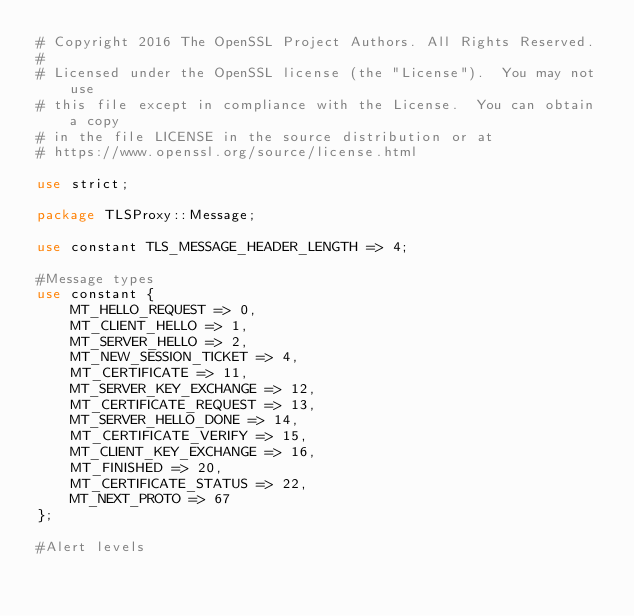<code> <loc_0><loc_0><loc_500><loc_500><_Perl_># Copyright 2016 The OpenSSL Project Authors. All Rights Reserved.
#
# Licensed under the OpenSSL license (the "License").  You may not use
# this file except in compliance with the License.  You can obtain a copy
# in the file LICENSE in the source distribution or at
# https://www.openssl.org/source/license.html

use strict;

package TLSProxy::Message;

use constant TLS_MESSAGE_HEADER_LENGTH => 4;

#Message types
use constant {
    MT_HELLO_REQUEST => 0,
    MT_CLIENT_HELLO => 1,
    MT_SERVER_HELLO => 2,
    MT_NEW_SESSION_TICKET => 4,
    MT_CERTIFICATE => 11,
    MT_SERVER_KEY_EXCHANGE => 12,
    MT_CERTIFICATE_REQUEST => 13,
    MT_SERVER_HELLO_DONE => 14,
    MT_CERTIFICATE_VERIFY => 15,
    MT_CLIENT_KEY_EXCHANGE => 16,
    MT_FINISHED => 20,
    MT_CERTIFICATE_STATUS => 22,
    MT_NEXT_PROTO => 67
};

#Alert levels</code> 